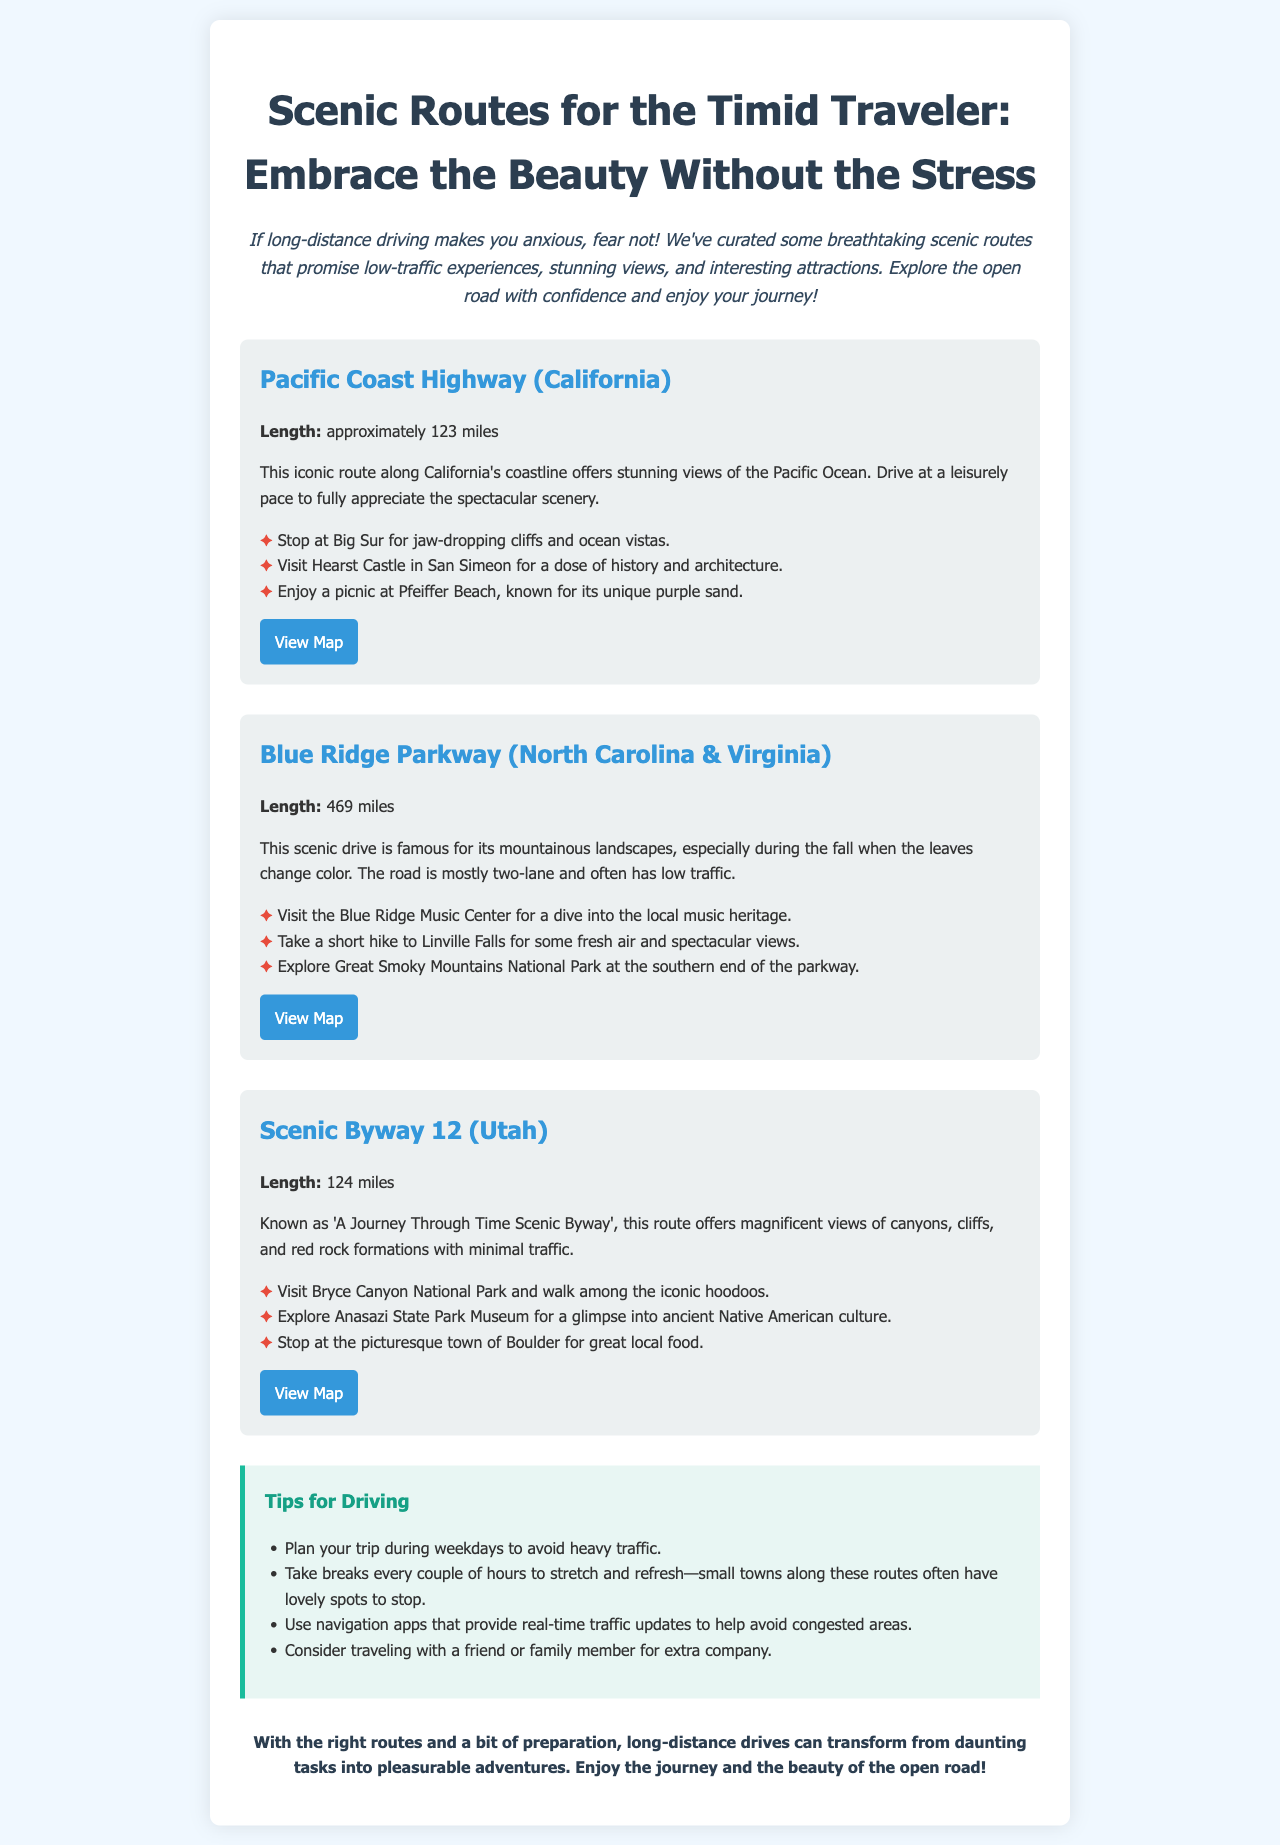What is the length of the Pacific Coast Highway? The length of the Pacific Coast Highway is mentioned as approximately 123 miles.
Answer: 123 miles What are the three highlights of the Blue Ridge Parkway? The highlights include visiting the Blue Ridge Music Center, hiking to Linville Falls, and exploring Great Smoky Mountains National Park.
Answer: Blue Ridge Music Center, Linville Falls, Great Smoky Mountains National Park What is the total length of the Scenic Byway 12? The document specifies the length of Scenic Byway 12 as 124 miles.
Answer: 124 miles What should you consider doing to avoid traffic during your trip? One suggestion provided is to plan your trip during weekdays to avoid heavy traffic.
Answer: Weekdays Which state's scenic route includes Bryce Canyon National Park? The scenic route that includes Bryce Canyon National Park is located in Utah.
Answer: Utah What is the main theme of the newsletter? The newsletter focuses on providing scenic route recommendations for those who feel anxious about long-distance driving.
Answer: Scenic route recommendations How many miles is the Blue Ridge Parkway? The document states the length of the Blue Ridge Parkway as 469 miles.
Answer: 469 miles What breaks does the document suggest taking during long drives? It suggests taking breaks every couple of hours to stretch and refresh.
Answer: Every couple of hours What type of landscapes does the Blue Ridge Parkway offer? The parkway is famous for its mountainous landscapes, particularly during fall.
Answer: Mountainous landscapes 